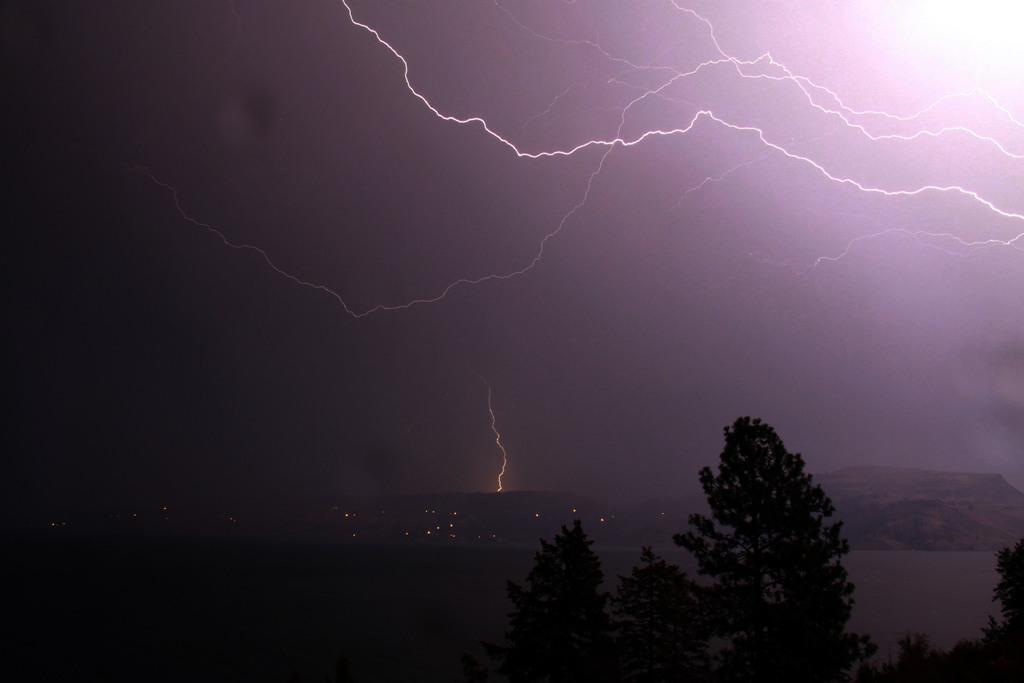In one or two sentences, can you explain what this image depicts? In the picture we can see some trees and behind far away we can see hills and lights and behind the hills we can see a sky with thunderstorms. 